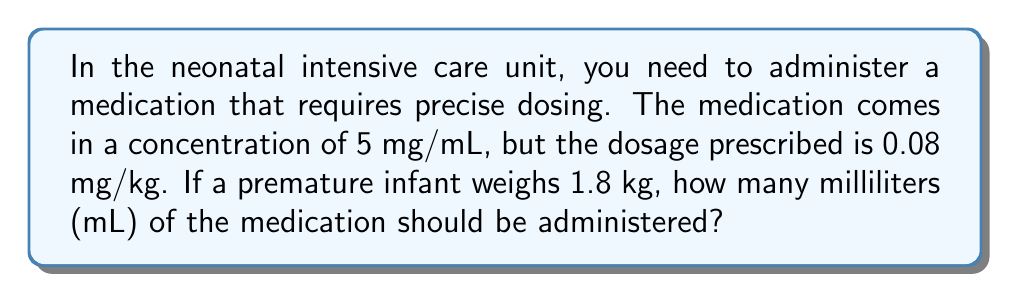Teach me how to tackle this problem. To solve this problem, we'll follow these steps:

1. Calculate the total dosage needed for the infant:
   Dosage = Weight × Prescribed dose per kg
   $$ \text{Dosage} = 1.8 \text{ kg} \times 0.08 \text{ mg/kg} = 0.144 \text{ mg} $$

2. Set up a proportion to convert from mg to mL:
   $$ \frac{5 \text{ mg}}{1 \text{ mL}} = \frac{0.144 \text{ mg}}{x \text{ mL}} $$

3. Cross multiply:
   $$ 5x = 0.144 $$

4. Solve for x:
   $$ x = \frac{0.144}{5} = 0.0288 \text{ mL} $$

5. Round to the nearest hundredth of a mL for practical administration:
   $$ 0.0288 \text{ mL} \approx 0.03 \text{ mL} $$
Answer: $0.03 \text{ mL}$ 